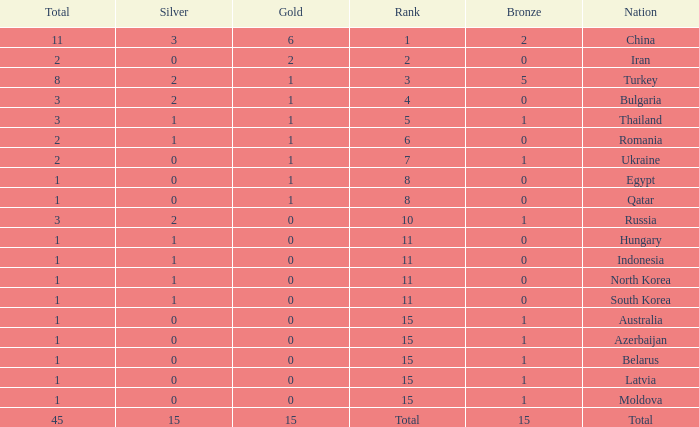What is the highest amount of bronze china, which has more than 1 gold and more than 11 total, has? None. Would you mind parsing the complete table? {'header': ['Total', 'Silver', 'Gold', 'Rank', 'Bronze', 'Nation'], 'rows': [['11', '3', '6', '1', '2', 'China'], ['2', '0', '2', '2', '0', 'Iran'], ['8', '2', '1', '3', '5', 'Turkey'], ['3', '2', '1', '4', '0', 'Bulgaria'], ['3', '1', '1', '5', '1', 'Thailand'], ['2', '1', '1', '6', '0', 'Romania'], ['2', '0', '1', '7', '1', 'Ukraine'], ['1', '0', '1', '8', '0', 'Egypt'], ['1', '0', '1', '8', '0', 'Qatar'], ['3', '2', '0', '10', '1', 'Russia'], ['1', '1', '0', '11', '0', 'Hungary'], ['1', '1', '0', '11', '0', 'Indonesia'], ['1', '1', '0', '11', '0', 'North Korea'], ['1', '1', '0', '11', '0', 'South Korea'], ['1', '0', '0', '15', '1', 'Australia'], ['1', '0', '0', '15', '1', 'Azerbaijan'], ['1', '0', '0', '15', '1', 'Belarus'], ['1', '0', '0', '15', '1', 'Latvia'], ['1', '0', '0', '15', '1', 'Moldova'], ['45', '15', '15', 'Total', '15', 'Total']]} 